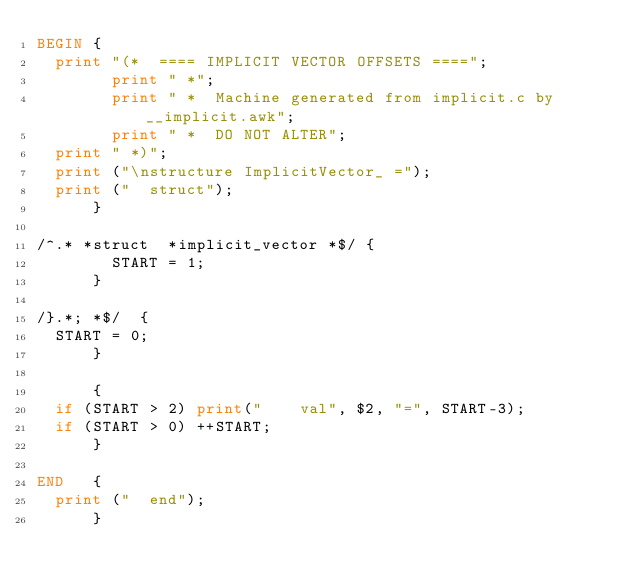Convert code to text. <code><loc_0><loc_0><loc_500><loc_500><_Awk_>BEGIN {
	print "(*  ==== IMPLICIT VECTOR OFFSETS ====";
        print " *";
        print " *  Machine generated from implicit.c by __implicit.awk";
        print " *  DO NOT ALTER";
	print " *)";
	print ("\nstructure ImplicitVector_ =");
	print ("  struct");
      }

/^.* *struct  *implicit_vector *$/ {
        START = 1;
      }

/}.*; *$/  {
	START = 0;
      }

      {
	if (START > 2) print("    val", $2, "=", START-3);
	if (START > 0) ++START;
      }

END   {
	print ("  end");
      }
</code> 